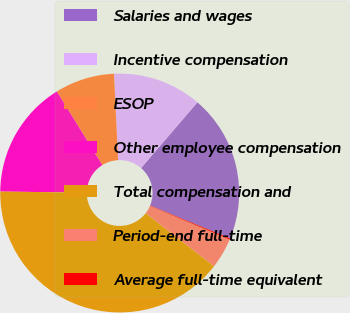Convert chart. <chart><loc_0><loc_0><loc_500><loc_500><pie_chart><fcel>Salaries and wages<fcel>Incentive compensation<fcel>ESOP<fcel>Other employee compensation<fcel>Total compensation and<fcel>Period-end full-time<fcel>Average full-time equivalent<nl><fcel>19.93%<fcel>12.03%<fcel>8.07%<fcel>15.98%<fcel>39.7%<fcel>4.12%<fcel>0.17%<nl></chart> 